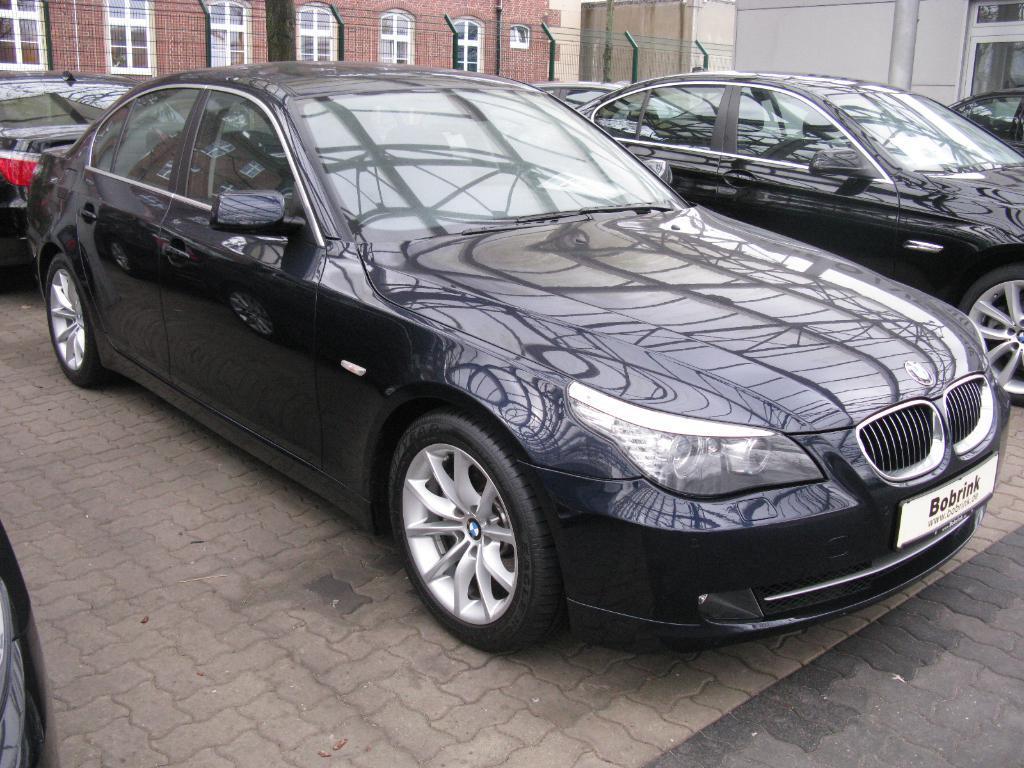How would you summarize this image in a sentence or two? In this image I can see few cars which are black in color on the ground. In the background I can see few buildings which are white and brown in color, few windows of the building which are white in color. 